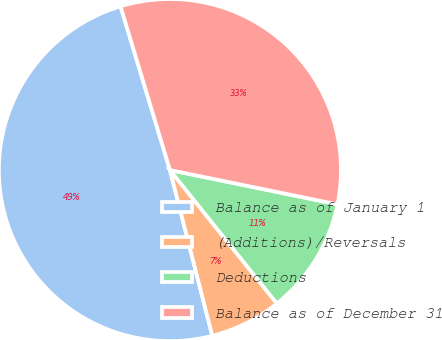Convert chart to OTSL. <chart><loc_0><loc_0><loc_500><loc_500><pie_chart><fcel>Balance as of January 1<fcel>(Additions)/Reversals<fcel>Deductions<fcel>Balance as of December 31<nl><fcel>49.32%<fcel>6.77%<fcel>11.03%<fcel>32.88%<nl></chart> 